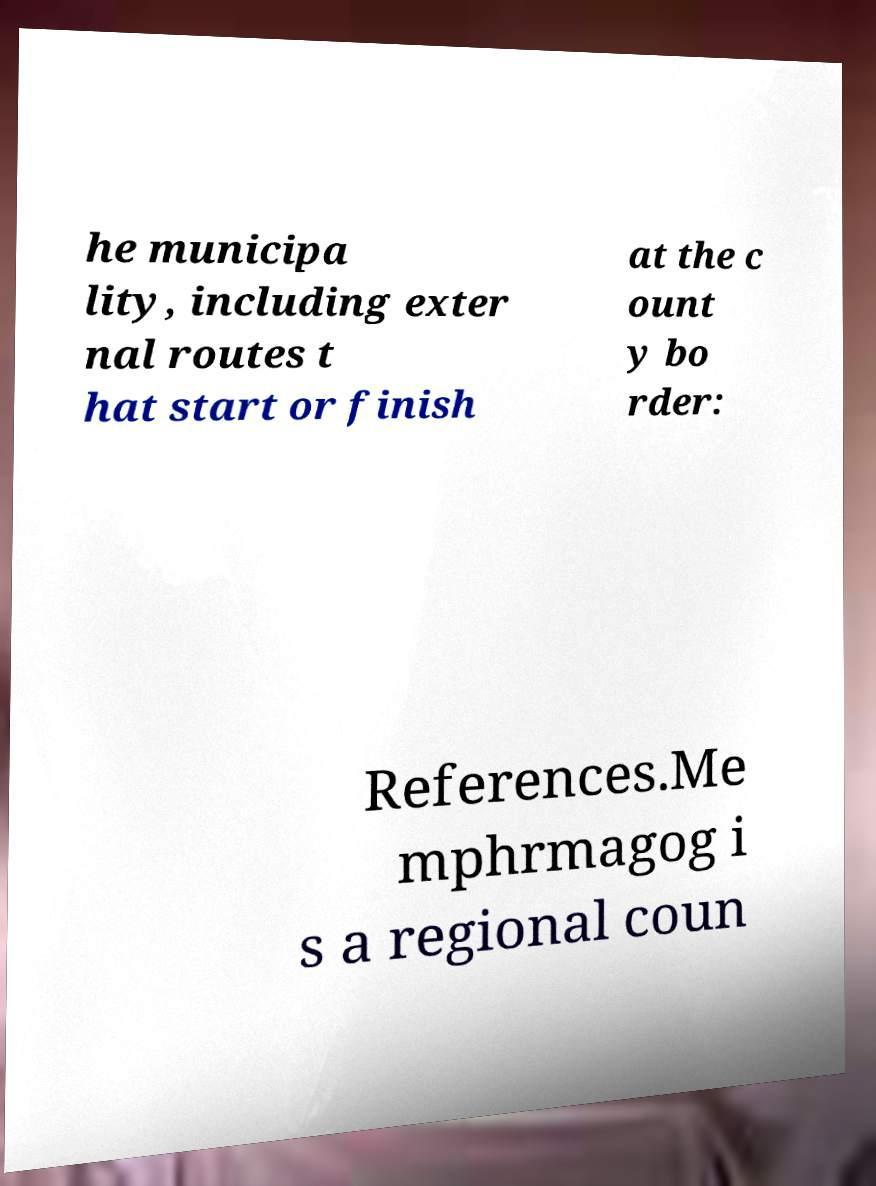Could you assist in decoding the text presented in this image and type it out clearly? he municipa lity, including exter nal routes t hat start or finish at the c ount y bo rder: References.Me mphrmagog i s a regional coun 